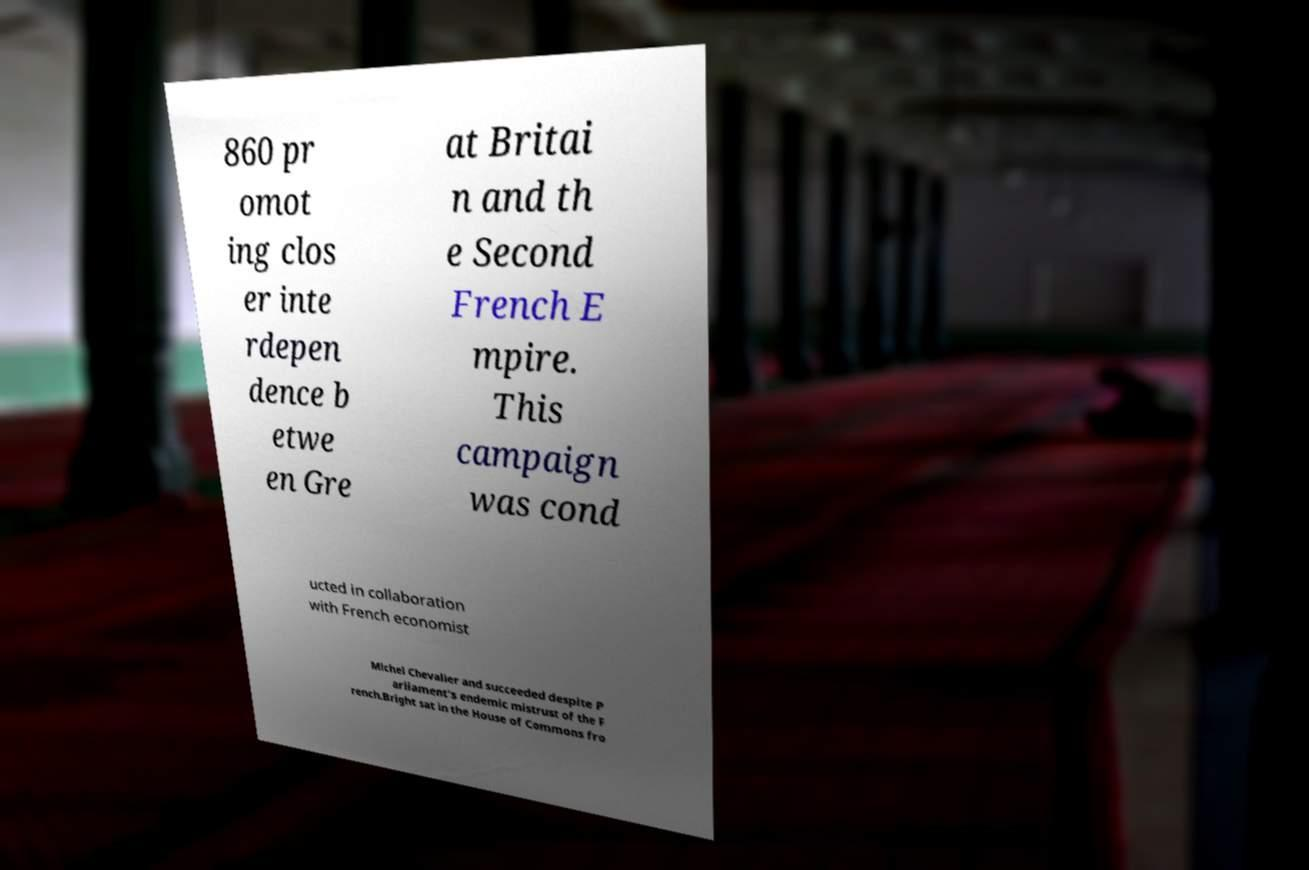Can you accurately transcribe the text from the provided image for me? 860 pr omot ing clos er inte rdepen dence b etwe en Gre at Britai n and th e Second French E mpire. This campaign was cond ucted in collaboration with French economist Michel Chevalier and succeeded despite P arliament's endemic mistrust of the F rench.Bright sat in the House of Commons fro 